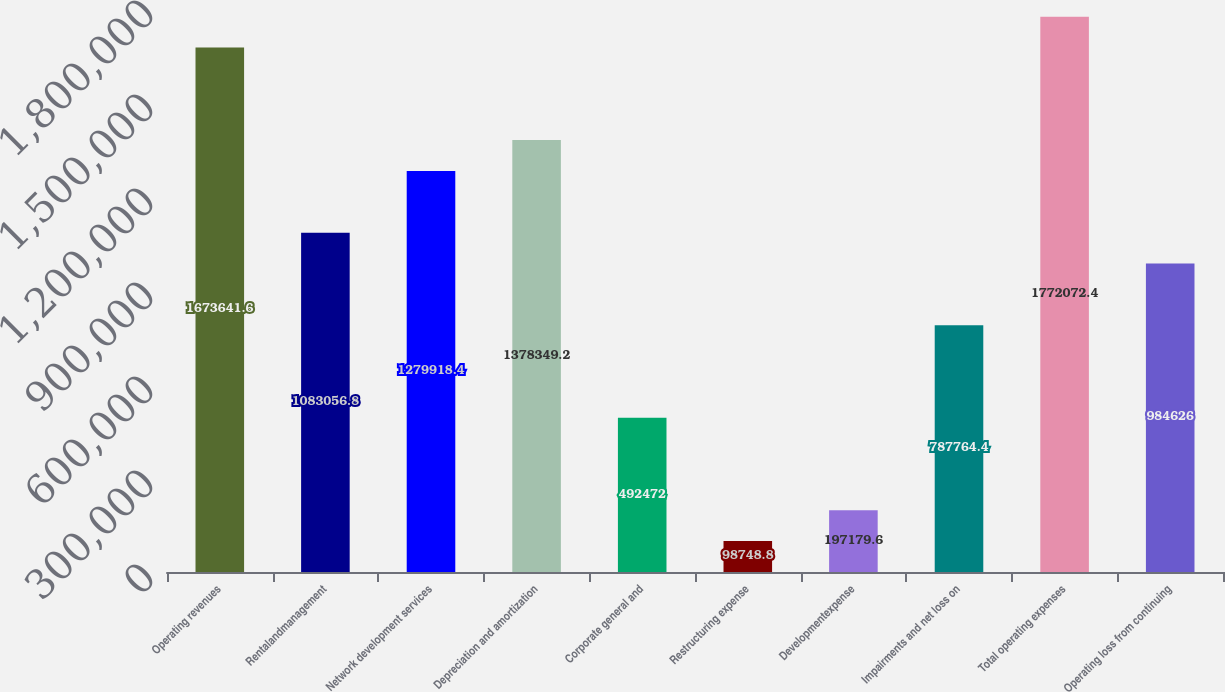Convert chart to OTSL. <chart><loc_0><loc_0><loc_500><loc_500><bar_chart><fcel>Operating revenues<fcel>Rentalandmanagement<fcel>Network development services<fcel>Depreciation and amortization<fcel>Corporate general and<fcel>Restructuring expense<fcel>Developmentexpense<fcel>Impairments and net loss on<fcel>Total operating expenses<fcel>Operating loss from continuing<nl><fcel>1.67364e+06<fcel>1.08306e+06<fcel>1.27992e+06<fcel>1.37835e+06<fcel>492472<fcel>98748.8<fcel>197180<fcel>787764<fcel>1.77207e+06<fcel>984626<nl></chart> 